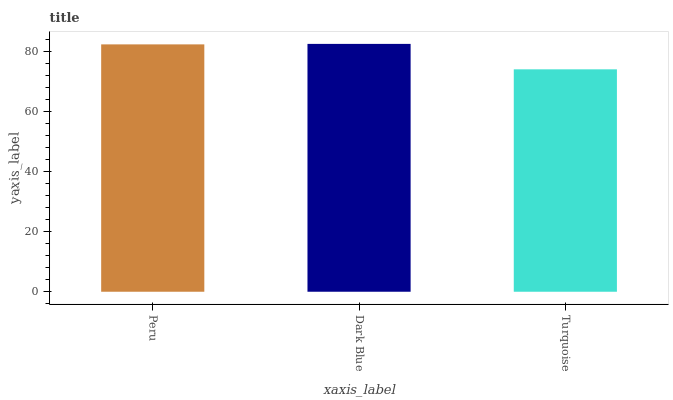Is Dark Blue the minimum?
Answer yes or no. No. Is Turquoise the maximum?
Answer yes or no. No. Is Dark Blue greater than Turquoise?
Answer yes or no. Yes. Is Turquoise less than Dark Blue?
Answer yes or no. Yes. Is Turquoise greater than Dark Blue?
Answer yes or no. No. Is Dark Blue less than Turquoise?
Answer yes or no. No. Is Peru the high median?
Answer yes or no. Yes. Is Peru the low median?
Answer yes or no. Yes. Is Turquoise the high median?
Answer yes or no. No. Is Dark Blue the low median?
Answer yes or no. No. 